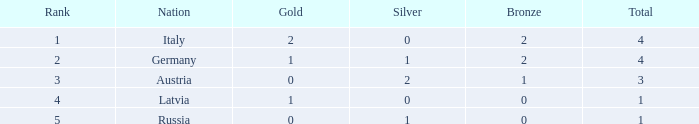What is the typical gold medals for countries with in excess of 0 bronze, beyond 0 silver, rank higher than 2, and total surpassing 3? None. 